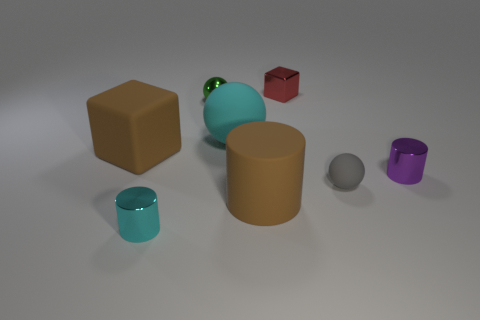Subtract all red balls. Subtract all gray cylinders. How many balls are left? 3 Add 2 large rubber balls. How many objects exist? 10 Subtract all balls. How many objects are left? 5 Subtract all large yellow cylinders. Subtract all large brown blocks. How many objects are left? 7 Add 2 tiny green metallic balls. How many tiny green metallic balls are left? 3 Add 8 large blue spheres. How many large blue spheres exist? 8 Subtract 1 purple cylinders. How many objects are left? 7 